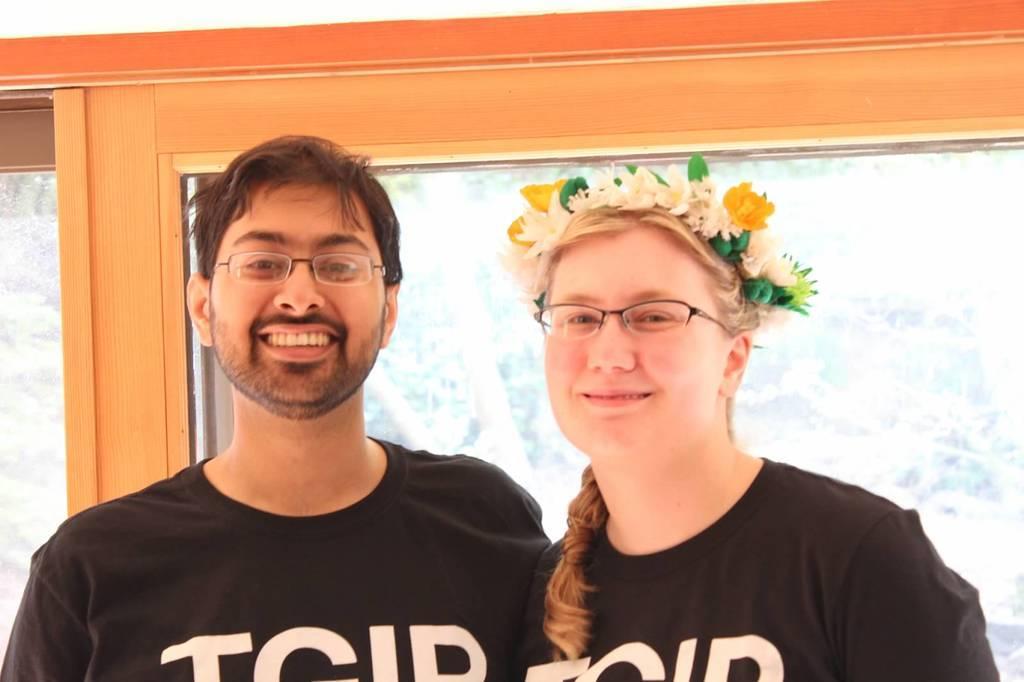Can you describe this image briefly? In the foreground of this picture, there is a couple standing and having smile on their faces. In the background, there is a glass and on the top, there is a wooden wall. 